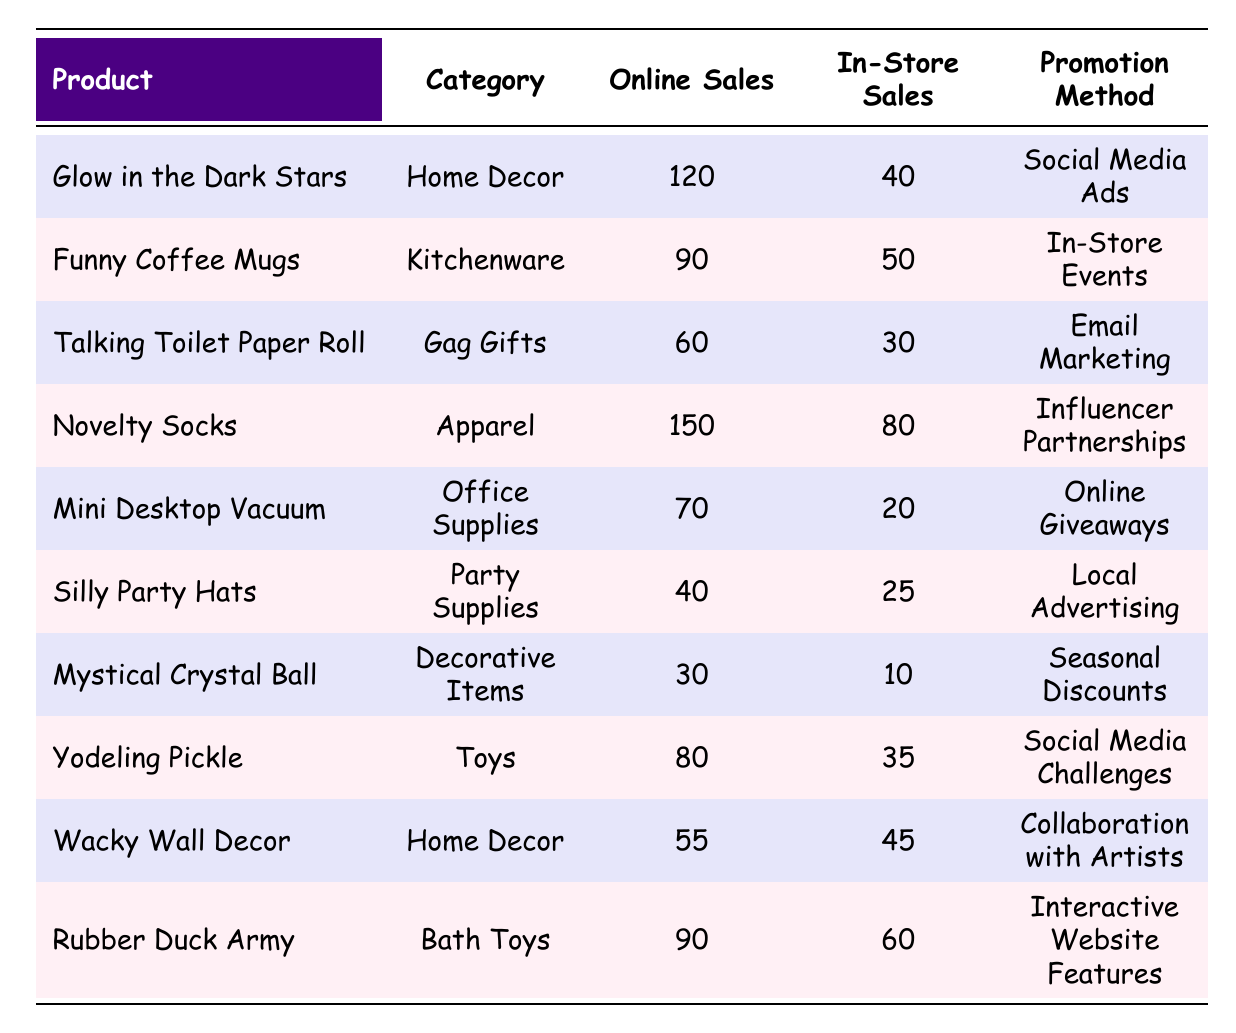What is the product with the highest online sales? Checking the online sales column, the product "Novelty Socks" shows the highest value of 150.
Answer: Novelty Socks How many more online sales did "Glow in the Dark Stars" achieve compared to in-store sales? For "Glow in the Dark Stars," online sales are 120 and in-store sales are 40. The difference is 120 - 40 = 80.
Answer: 80 Did "Mini Desktop Vacuum" have more online sales than in-store sales? "Mini Desktop Vacuum" had 70 online sales and 20 in-store sales, so yes, it had more online sales than in-store sales.
Answer: Yes What is the total of online sales for all products listed? Summing the online sales: 120 + 90 + 60 + 150 + 70 + 40 + 30 + 80 + 55 + 90 = 795.
Answer: 795 Is it true that "Rubber Duck Army" had more in-store sales than "Yodeling Pickle"? "Rubber Duck Army" had 60 in-store sales, and "Yodeling Pickle" had 35. Since 60 > 35, this statement is true.
Answer: Yes What is the average number of in-store sales across all products? Adding the in-store sales: 40 + 50 + 30 + 80 + 20 + 25 + 10 + 35 + 45 + 60 = 350. Dividing by the number of products (10), the average is 350 / 10 = 35.
Answer: 35 Which promotion method led to the highest online sales? "Novelty Socks" with influencer partnerships had the highest online sales of 150, making it the top promotion method among the listed products.
Answer: Influencer Partnerships How many products had online sales greater than 75? The products with online sales greater than 75 are: "Glow in the Dark Stars," "Novelty Socks," "Rubber Duck Army," and "Funny Coffee Mugs," resulting in a total of 4 products.
Answer: 4 What is the difference between the highest and lowest in-store sales? The highest in-store sales is 80 (Novelty Socks), and the lowest is 10 (Mystical Crystal Ball). The difference is 80 - 10 = 70.
Answer: 70 